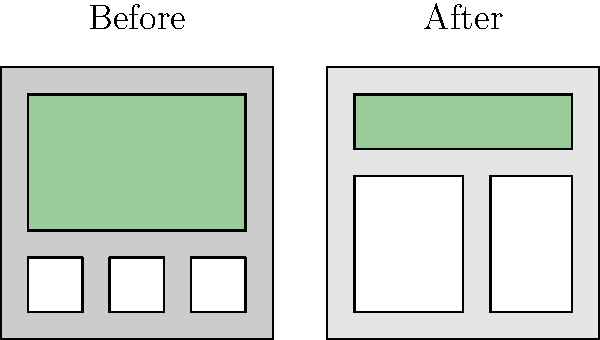Based on the before-and-after sketches of the neighborhood, what is the most significant impact of the proposed zoning changes, and how might this affect community dynamics? To assess the impact of the proposed zoning changes, we need to analyze the differences between the "Before" and "After" sketches:

1. Housing density:
   - Before: Three small, detached houses
   - After: Two large apartment buildings
   
2. Green space:
   - Before: Large green area covering most of the neighborhood
   - After: Significantly reduced green space

3. Building height:
   - Before: Single-story houses
   - After: Multi-story apartment buildings

The most significant impact is the increase in housing density and the reduction of green space. This change will likely affect the community in several ways:

1. Population increase: More residents can be accommodated in the apartment buildings.
2. Loss of open space: Less area for recreation and community gatherings.
3. Potential strain on local infrastructure: More residents may lead to increased demand for services.
4. Change in neighborhood character: Shift from a low-density, single-family area to a higher-density, multi-family zone.
5. Possible impact on property values: Depending on the local market, this could increase or decrease property values.
6. Environmental concerns: Reduction in green space may affect local ecosystems and air quality.

These changes are likely to significantly alter community dynamics by changing the mix of residents, the way people interact with their environment, and the overall feel of the neighborhood.
Answer: Increased housing density and reduced green space, leading to potential changes in community composition and interactions. 